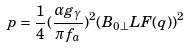Convert formula to latex. <formula><loc_0><loc_0><loc_500><loc_500>p = { \frac { 1 } { 4 } } ( { \frac { \alpha g _ { \gamma } } { \pi f _ { a } } } ) ^ { 2 } ( B _ { 0 \perp } L F ( q ) ) ^ { 2 }</formula> 